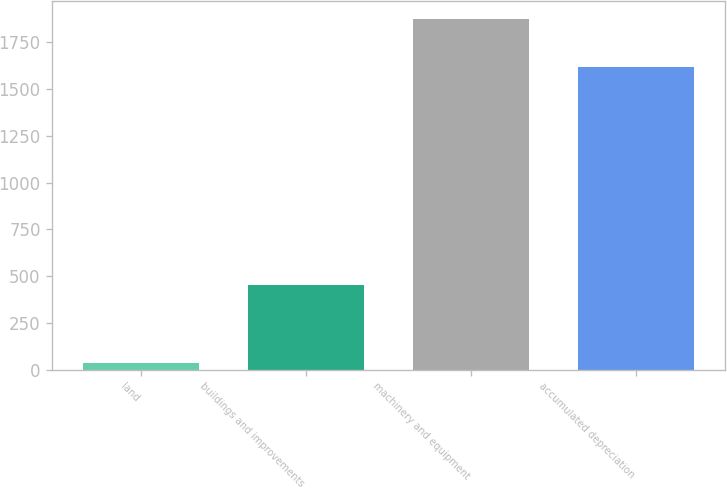<chart> <loc_0><loc_0><loc_500><loc_500><bar_chart><fcel>land<fcel>buildings and improvements<fcel>machinery and equipment<fcel>accumulated depreciation<nl><fcel>34.1<fcel>452.9<fcel>1876.7<fcel>1616.8<nl></chart> 